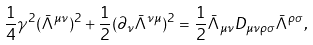Convert formula to latex. <formula><loc_0><loc_0><loc_500><loc_500>\frac { 1 } { 4 } \gamma ^ { 2 } ( \bar { \Lambda } ^ { \mu \nu } ) ^ { 2 } + \frac { 1 } { 2 } ( \partial _ { \nu } \bar { \Lambda } ^ { \nu \mu } ) ^ { 2 } = \frac { 1 } { 2 } \bar { \Lambda } _ { \mu \nu } D _ { \mu \nu \rho \sigma } \bar { \Lambda } ^ { \rho \sigma } ,</formula> 